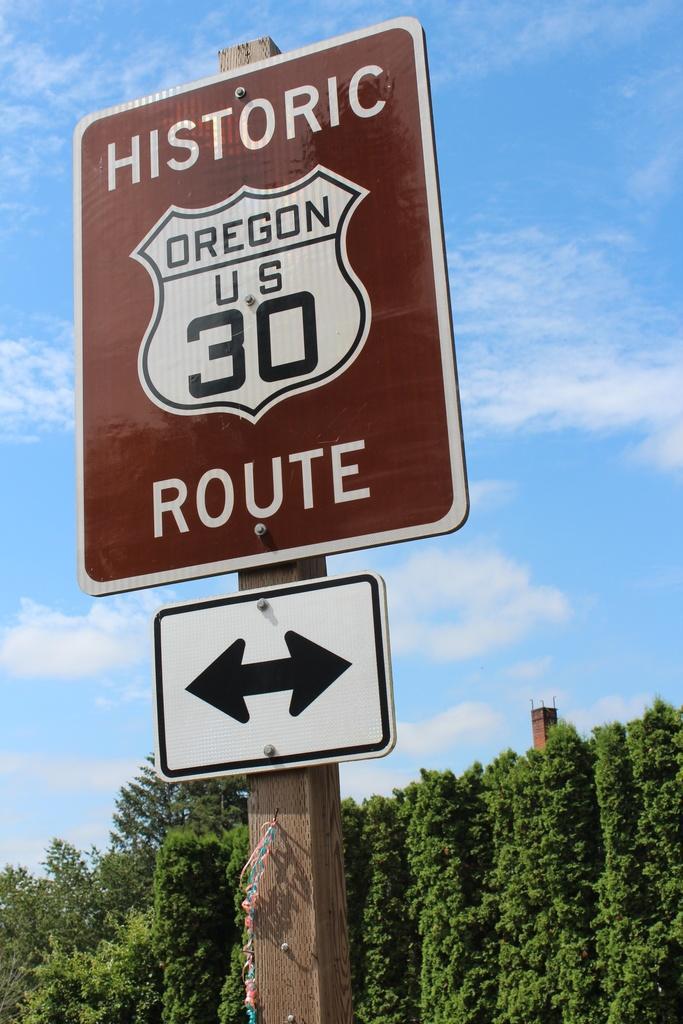Please provide a concise description of this image. In this image there is a pole for that pole there is a board, on that board there is some text, in the background there are trees and the sky. 